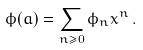<formula> <loc_0><loc_0><loc_500><loc_500>\phi ( a ) = \sum _ { n \geq 0 } \phi _ { n } x ^ { n } \, .</formula> 